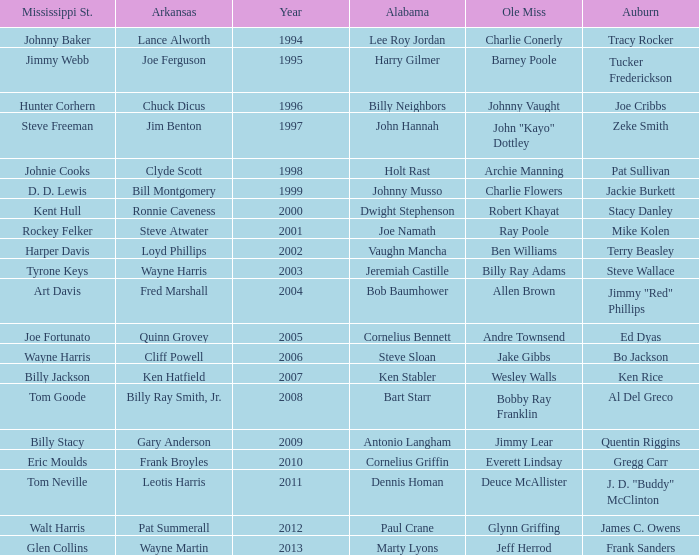Who was the player associated with Ole Miss in years after 2008 with a Mississippi St. name of Eric Moulds? Everett Lindsay. 